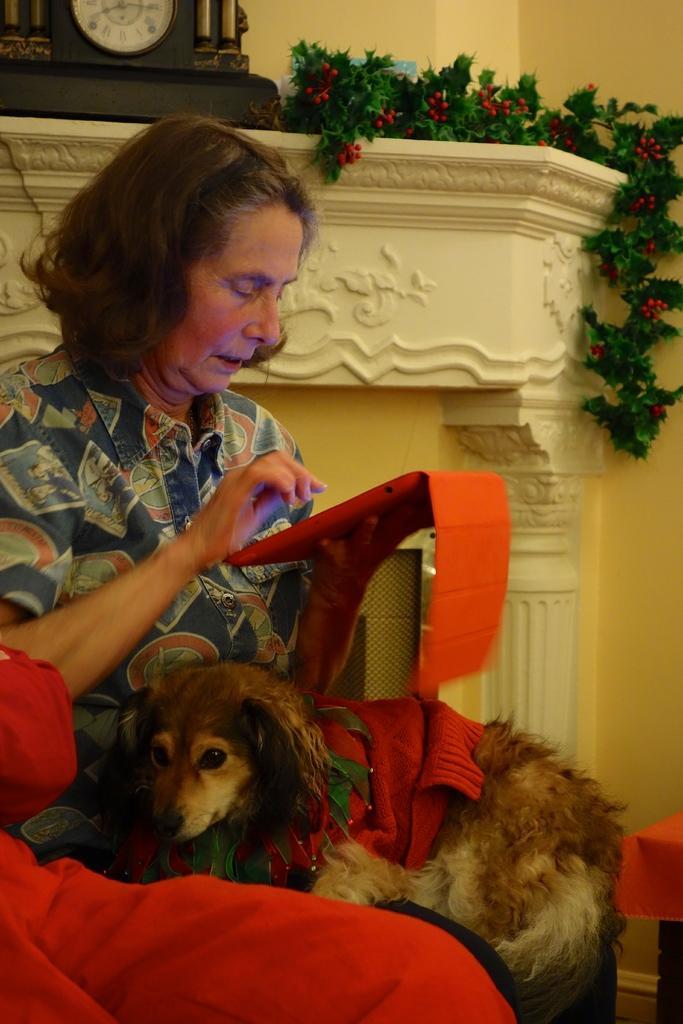In one or two sentences, can you explain what this image depicts? In this image a lady is sitting on her lap a dog is there. She is holding a tablet. Behind her there is a clock and plant. 